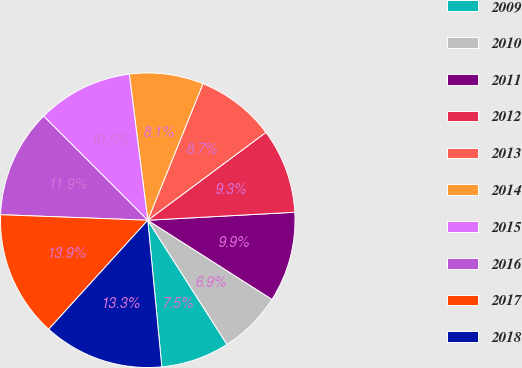Convert chart to OTSL. <chart><loc_0><loc_0><loc_500><loc_500><pie_chart><fcel>2009<fcel>2010<fcel>2011<fcel>2012<fcel>2013<fcel>2014<fcel>2015<fcel>2016<fcel>2017<fcel>2018<nl><fcel>7.52%<fcel>6.93%<fcel>9.9%<fcel>9.31%<fcel>8.71%<fcel>8.12%<fcel>10.5%<fcel>11.9%<fcel>13.86%<fcel>13.26%<nl></chart> 